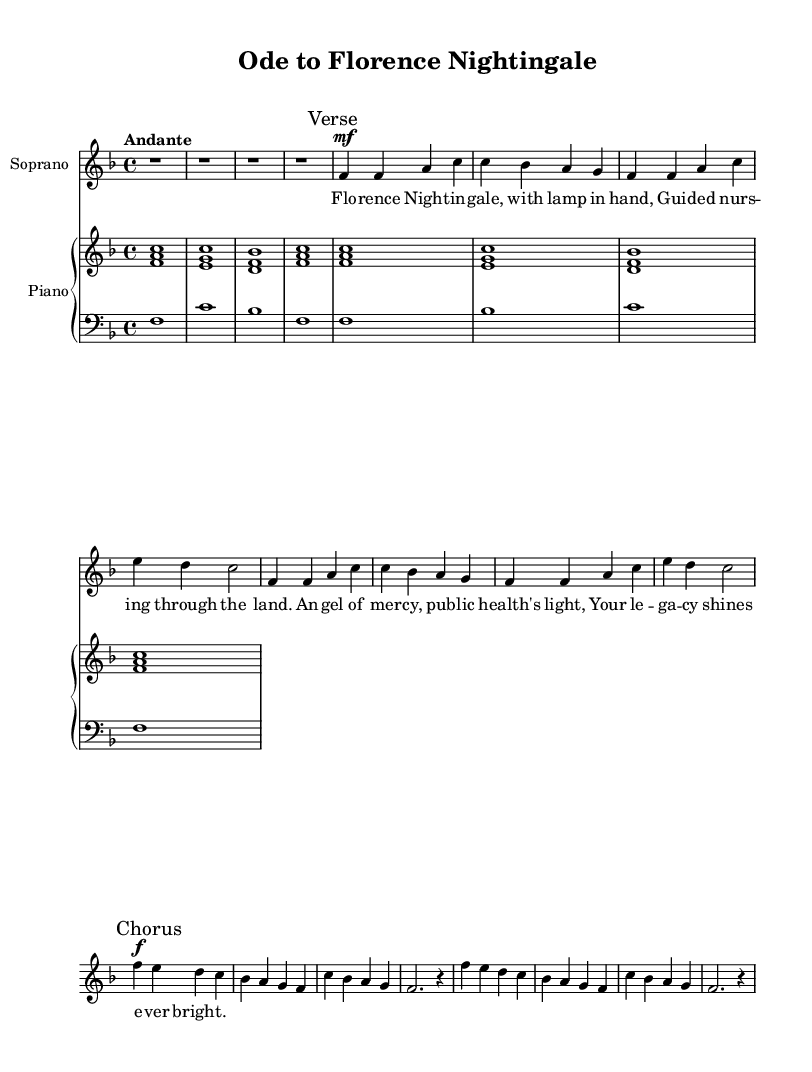what is the key signature of this music? The key signature is indicated at the beginning of the music sheet by the presence of one flat, which corresponds to the key of F major (one flat in the key signature).
Answer: F major what is the time signature of this music? The time signature is located at the beginning of the score and is indicated as 4/4, meaning there are four beats in a measure and the quarter note gets one beat.
Answer: 4/4 what is the tempo marking for this music? The tempo marking is shown above the music and is indicated as "Andante," which means a moderately slow tempo.
Answer: Andante how many verses does this piece contain? The music contains one verse, which is clearly marked with a "Verse" indication in the score.
Answer: One what dynamics are indicated for the chorus? The part labeled "Chorus" indicates a forte dynamic, which is denoted by the symbol "f" next to the notes.
Answer: Forte what is the main theme of the lyrics? The lyrics convey admiration for Florence Nightingale and highlight her contributions to public health and nursing, describing her as a guiding light and a legacy.
Answer: Florence Nightingale's contributions how many measures are there in the first verse? The first verse consists of two repeated sections, with a total of 8 measures (4 in each section).
Answer: Eight measures 